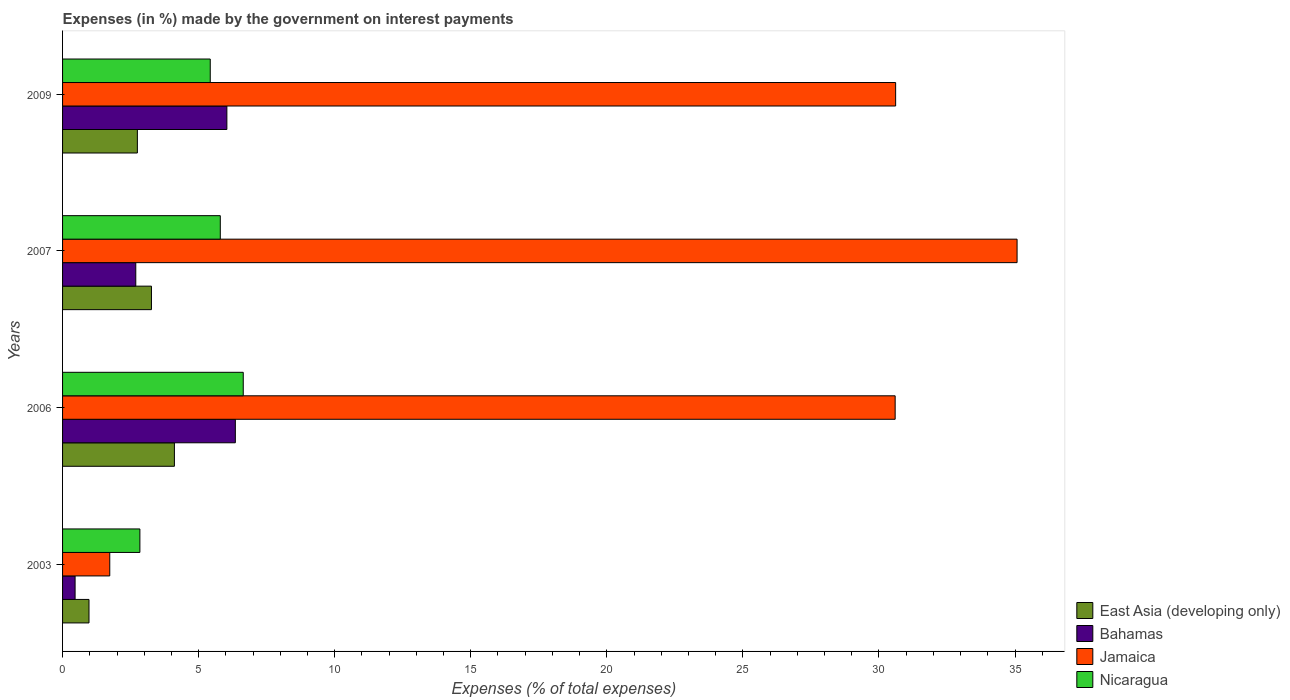How many different coloured bars are there?
Provide a short and direct response. 4. How many groups of bars are there?
Ensure brevity in your answer.  4. Are the number of bars per tick equal to the number of legend labels?
Offer a terse response. Yes. Are the number of bars on each tick of the Y-axis equal?
Give a very brief answer. Yes. What is the label of the 3rd group of bars from the top?
Offer a terse response. 2006. What is the percentage of expenses made by the government on interest payments in Bahamas in 2006?
Provide a succinct answer. 6.35. Across all years, what is the maximum percentage of expenses made by the government on interest payments in Bahamas?
Your answer should be compact. 6.35. Across all years, what is the minimum percentage of expenses made by the government on interest payments in Bahamas?
Provide a succinct answer. 0.46. What is the total percentage of expenses made by the government on interest payments in Bahamas in the graph?
Offer a very short reply. 15.54. What is the difference between the percentage of expenses made by the government on interest payments in Jamaica in 2003 and that in 2006?
Offer a very short reply. -28.86. What is the difference between the percentage of expenses made by the government on interest payments in Nicaragua in 2006 and the percentage of expenses made by the government on interest payments in East Asia (developing only) in 2007?
Your response must be concise. 3.37. What is the average percentage of expenses made by the government on interest payments in Bahamas per year?
Your answer should be very brief. 3.88. In the year 2009, what is the difference between the percentage of expenses made by the government on interest payments in Jamaica and percentage of expenses made by the government on interest payments in Bahamas?
Offer a very short reply. 24.57. In how many years, is the percentage of expenses made by the government on interest payments in Bahamas greater than 20 %?
Offer a very short reply. 0. What is the ratio of the percentage of expenses made by the government on interest payments in Bahamas in 2003 to that in 2009?
Ensure brevity in your answer.  0.08. Is the percentage of expenses made by the government on interest payments in Nicaragua in 2003 less than that in 2009?
Ensure brevity in your answer.  Yes. What is the difference between the highest and the second highest percentage of expenses made by the government on interest payments in Bahamas?
Your answer should be very brief. 0.31. What is the difference between the highest and the lowest percentage of expenses made by the government on interest payments in Nicaragua?
Keep it short and to the point. 3.8. In how many years, is the percentage of expenses made by the government on interest payments in East Asia (developing only) greater than the average percentage of expenses made by the government on interest payments in East Asia (developing only) taken over all years?
Offer a terse response. 2. Is it the case that in every year, the sum of the percentage of expenses made by the government on interest payments in Nicaragua and percentage of expenses made by the government on interest payments in Bahamas is greater than the sum of percentage of expenses made by the government on interest payments in Jamaica and percentage of expenses made by the government on interest payments in East Asia (developing only)?
Ensure brevity in your answer.  No. What does the 2nd bar from the top in 2007 represents?
Your answer should be compact. Jamaica. What does the 4th bar from the bottom in 2003 represents?
Your response must be concise. Nicaragua. Is it the case that in every year, the sum of the percentage of expenses made by the government on interest payments in Nicaragua and percentage of expenses made by the government on interest payments in Bahamas is greater than the percentage of expenses made by the government on interest payments in Jamaica?
Give a very brief answer. No. How many bars are there?
Your answer should be very brief. 16. Are all the bars in the graph horizontal?
Offer a terse response. Yes. What is the difference between two consecutive major ticks on the X-axis?
Offer a very short reply. 5. Are the values on the major ticks of X-axis written in scientific E-notation?
Offer a terse response. No. Does the graph contain any zero values?
Make the answer very short. No. Where does the legend appear in the graph?
Your answer should be very brief. Bottom right. What is the title of the graph?
Make the answer very short. Expenses (in %) made by the government on interest payments. What is the label or title of the X-axis?
Keep it short and to the point. Expenses (% of total expenses). What is the Expenses (% of total expenses) in East Asia (developing only) in 2003?
Give a very brief answer. 0.97. What is the Expenses (% of total expenses) of Bahamas in 2003?
Provide a succinct answer. 0.46. What is the Expenses (% of total expenses) of Jamaica in 2003?
Keep it short and to the point. 1.73. What is the Expenses (% of total expenses) of Nicaragua in 2003?
Your answer should be very brief. 2.84. What is the Expenses (% of total expenses) in East Asia (developing only) in 2006?
Make the answer very short. 4.11. What is the Expenses (% of total expenses) in Bahamas in 2006?
Your response must be concise. 6.35. What is the Expenses (% of total expenses) of Jamaica in 2006?
Provide a succinct answer. 30.6. What is the Expenses (% of total expenses) of Nicaragua in 2006?
Provide a succinct answer. 6.64. What is the Expenses (% of total expenses) in East Asia (developing only) in 2007?
Make the answer very short. 3.27. What is the Expenses (% of total expenses) in Bahamas in 2007?
Give a very brief answer. 2.69. What is the Expenses (% of total expenses) of Jamaica in 2007?
Make the answer very short. 35.08. What is the Expenses (% of total expenses) in Nicaragua in 2007?
Offer a terse response. 5.8. What is the Expenses (% of total expenses) of East Asia (developing only) in 2009?
Keep it short and to the point. 2.75. What is the Expenses (% of total expenses) in Bahamas in 2009?
Make the answer very short. 6.04. What is the Expenses (% of total expenses) in Jamaica in 2009?
Provide a short and direct response. 30.61. What is the Expenses (% of total expenses) of Nicaragua in 2009?
Ensure brevity in your answer.  5.43. Across all years, what is the maximum Expenses (% of total expenses) in East Asia (developing only)?
Provide a succinct answer. 4.11. Across all years, what is the maximum Expenses (% of total expenses) in Bahamas?
Your response must be concise. 6.35. Across all years, what is the maximum Expenses (% of total expenses) of Jamaica?
Your answer should be very brief. 35.08. Across all years, what is the maximum Expenses (% of total expenses) of Nicaragua?
Keep it short and to the point. 6.64. Across all years, what is the minimum Expenses (% of total expenses) of East Asia (developing only)?
Your answer should be compact. 0.97. Across all years, what is the minimum Expenses (% of total expenses) of Bahamas?
Your response must be concise. 0.46. Across all years, what is the minimum Expenses (% of total expenses) of Jamaica?
Offer a terse response. 1.73. Across all years, what is the minimum Expenses (% of total expenses) of Nicaragua?
Provide a short and direct response. 2.84. What is the total Expenses (% of total expenses) of East Asia (developing only) in the graph?
Offer a terse response. 11.1. What is the total Expenses (% of total expenses) in Bahamas in the graph?
Your response must be concise. 15.54. What is the total Expenses (% of total expenses) in Jamaica in the graph?
Give a very brief answer. 98.02. What is the total Expenses (% of total expenses) of Nicaragua in the graph?
Give a very brief answer. 20.7. What is the difference between the Expenses (% of total expenses) in East Asia (developing only) in 2003 and that in 2006?
Your answer should be very brief. -3.14. What is the difference between the Expenses (% of total expenses) in Bahamas in 2003 and that in 2006?
Your response must be concise. -5.89. What is the difference between the Expenses (% of total expenses) of Jamaica in 2003 and that in 2006?
Provide a succinct answer. -28.86. What is the difference between the Expenses (% of total expenses) in Nicaragua in 2003 and that in 2006?
Your answer should be very brief. -3.8. What is the difference between the Expenses (% of total expenses) in East Asia (developing only) in 2003 and that in 2007?
Keep it short and to the point. -2.29. What is the difference between the Expenses (% of total expenses) of Bahamas in 2003 and that in 2007?
Keep it short and to the point. -2.23. What is the difference between the Expenses (% of total expenses) in Jamaica in 2003 and that in 2007?
Your response must be concise. -33.34. What is the difference between the Expenses (% of total expenses) in Nicaragua in 2003 and that in 2007?
Your answer should be compact. -2.95. What is the difference between the Expenses (% of total expenses) in East Asia (developing only) in 2003 and that in 2009?
Ensure brevity in your answer.  -1.78. What is the difference between the Expenses (% of total expenses) in Bahamas in 2003 and that in 2009?
Offer a terse response. -5.58. What is the difference between the Expenses (% of total expenses) of Jamaica in 2003 and that in 2009?
Provide a short and direct response. -28.88. What is the difference between the Expenses (% of total expenses) of Nicaragua in 2003 and that in 2009?
Offer a terse response. -2.59. What is the difference between the Expenses (% of total expenses) in East Asia (developing only) in 2006 and that in 2007?
Your answer should be compact. 0.84. What is the difference between the Expenses (% of total expenses) of Bahamas in 2006 and that in 2007?
Your answer should be compact. 3.66. What is the difference between the Expenses (% of total expenses) of Jamaica in 2006 and that in 2007?
Give a very brief answer. -4.48. What is the difference between the Expenses (% of total expenses) of Nicaragua in 2006 and that in 2007?
Your answer should be very brief. 0.84. What is the difference between the Expenses (% of total expenses) in East Asia (developing only) in 2006 and that in 2009?
Your answer should be compact. 1.36. What is the difference between the Expenses (% of total expenses) of Bahamas in 2006 and that in 2009?
Provide a short and direct response. 0.31. What is the difference between the Expenses (% of total expenses) in Jamaica in 2006 and that in 2009?
Offer a very short reply. -0.02. What is the difference between the Expenses (% of total expenses) in Nicaragua in 2006 and that in 2009?
Offer a very short reply. 1.21. What is the difference between the Expenses (% of total expenses) of East Asia (developing only) in 2007 and that in 2009?
Your answer should be very brief. 0.52. What is the difference between the Expenses (% of total expenses) of Bahamas in 2007 and that in 2009?
Make the answer very short. -3.35. What is the difference between the Expenses (% of total expenses) in Jamaica in 2007 and that in 2009?
Your response must be concise. 4.46. What is the difference between the Expenses (% of total expenses) in Nicaragua in 2007 and that in 2009?
Make the answer very short. 0.37. What is the difference between the Expenses (% of total expenses) of East Asia (developing only) in 2003 and the Expenses (% of total expenses) of Bahamas in 2006?
Provide a succinct answer. -5.38. What is the difference between the Expenses (% of total expenses) of East Asia (developing only) in 2003 and the Expenses (% of total expenses) of Jamaica in 2006?
Provide a succinct answer. -29.62. What is the difference between the Expenses (% of total expenses) of East Asia (developing only) in 2003 and the Expenses (% of total expenses) of Nicaragua in 2006?
Your answer should be very brief. -5.67. What is the difference between the Expenses (% of total expenses) of Bahamas in 2003 and the Expenses (% of total expenses) of Jamaica in 2006?
Keep it short and to the point. -30.13. What is the difference between the Expenses (% of total expenses) in Bahamas in 2003 and the Expenses (% of total expenses) in Nicaragua in 2006?
Ensure brevity in your answer.  -6.18. What is the difference between the Expenses (% of total expenses) of Jamaica in 2003 and the Expenses (% of total expenses) of Nicaragua in 2006?
Keep it short and to the point. -4.91. What is the difference between the Expenses (% of total expenses) in East Asia (developing only) in 2003 and the Expenses (% of total expenses) in Bahamas in 2007?
Make the answer very short. -1.72. What is the difference between the Expenses (% of total expenses) in East Asia (developing only) in 2003 and the Expenses (% of total expenses) in Jamaica in 2007?
Your response must be concise. -34.1. What is the difference between the Expenses (% of total expenses) in East Asia (developing only) in 2003 and the Expenses (% of total expenses) in Nicaragua in 2007?
Your response must be concise. -4.82. What is the difference between the Expenses (% of total expenses) in Bahamas in 2003 and the Expenses (% of total expenses) in Jamaica in 2007?
Ensure brevity in your answer.  -34.61. What is the difference between the Expenses (% of total expenses) in Bahamas in 2003 and the Expenses (% of total expenses) in Nicaragua in 2007?
Make the answer very short. -5.34. What is the difference between the Expenses (% of total expenses) of Jamaica in 2003 and the Expenses (% of total expenses) of Nicaragua in 2007?
Provide a succinct answer. -4.06. What is the difference between the Expenses (% of total expenses) in East Asia (developing only) in 2003 and the Expenses (% of total expenses) in Bahamas in 2009?
Your response must be concise. -5.07. What is the difference between the Expenses (% of total expenses) of East Asia (developing only) in 2003 and the Expenses (% of total expenses) of Jamaica in 2009?
Offer a terse response. -29.64. What is the difference between the Expenses (% of total expenses) in East Asia (developing only) in 2003 and the Expenses (% of total expenses) in Nicaragua in 2009?
Provide a succinct answer. -4.46. What is the difference between the Expenses (% of total expenses) of Bahamas in 2003 and the Expenses (% of total expenses) of Jamaica in 2009?
Give a very brief answer. -30.15. What is the difference between the Expenses (% of total expenses) of Bahamas in 2003 and the Expenses (% of total expenses) of Nicaragua in 2009?
Offer a terse response. -4.97. What is the difference between the Expenses (% of total expenses) in Jamaica in 2003 and the Expenses (% of total expenses) in Nicaragua in 2009?
Your response must be concise. -3.69. What is the difference between the Expenses (% of total expenses) in East Asia (developing only) in 2006 and the Expenses (% of total expenses) in Bahamas in 2007?
Offer a terse response. 1.42. What is the difference between the Expenses (% of total expenses) in East Asia (developing only) in 2006 and the Expenses (% of total expenses) in Jamaica in 2007?
Your answer should be very brief. -30.97. What is the difference between the Expenses (% of total expenses) of East Asia (developing only) in 2006 and the Expenses (% of total expenses) of Nicaragua in 2007?
Offer a very short reply. -1.69. What is the difference between the Expenses (% of total expenses) in Bahamas in 2006 and the Expenses (% of total expenses) in Jamaica in 2007?
Offer a very short reply. -28.73. What is the difference between the Expenses (% of total expenses) of Bahamas in 2006 and the Expenses (% of total expenses) of Nicaragua in 2007?
Provide a short and direct response. 0.55. What is the difference between the Expenses (% of total expenses) in Jamaica in 2006 and the Expenses (% of total expenses) in Nicaragua in 2007?
Keep it short and to the point. 24.8. What is the difference between the Expenses (% of total expenses) of East Asia (developing only) in 2006 and the Expenses (% of total expenses) of Bahamas in 2009?
Your response must be concise. -1.93. What is the difference between the Expenses (% of total expenses) in East Asia (developing only) in 2006 and the Expenses (% of total expenses) in Jamaica in 2009?
Your answer should be compact. -26.5. What is the difference between the Expenses (% of total expenses) of East Asia (developing only) in 2006 and the Expenses (% of total expenses) of Nicaragua in 2009?
Provide a short and direct response. -1.32. What is the difference between the Expenses (% of total expenses) of Bahamas in 2006 and the Expenses (% of total expenses) of Jamaica in 2009?
Give a very brief answer. -24.26. What is the difference between the Expenses (% of total expenses) in Bahamas in 2006 and the Expenses (% of total expenses) in Nicaragua in 2009?
Offer a very short reply. 0.92. What is the difference between the Expenses (% of total expenses) in Jamaica in 2006 and the Expenses (% of total expenses) in Nicaragua in 2009?
Provide a short and direct response. 25.17. What is the difference between the Expenses (% of total expenses) in East Asia (developing only) in 2007 and the Expenses (% of total expenses) in Bahamas in 2009?
Provide a short and direct response. -2.77. What is the difference between the Expenses (% of total expenses) in East Asia (developing only) in 2007 and the Expenses (% of total expenses) in Jamaica in 2009?
Provide a succinct answer. -27.35. What is the difference between the Expenses (% of total expenses) of East Asia (developing only) in 2007 and the Expenses (% of total expenses) of Nicaragua in 2009?
Provide a short and direct response. -2.16. What is the difference between the Expenses (% of total expenses) in Bahamas in 2007 and the Expenses (% of total expenses) in Jamaica in 2009?
Provide a short and direct response. -27.92. What is the difference between the Expenses (% of total expenses) of Bahamas in 2007 and the Expenses (% of total expenses) of Nicaragua in 2009?
Offer a very short reply. -2.74. What is the difference between the Expenses (% of total expenses) of Jamaica in 2007 and the Expenses (% of total expenses) of Nicaragua in 2009?
Provide a succinct answer. 29.65. What is the average Expenses (% of total expenses) in East Asia (developing only) per year?
Your answer should be compact. 2.77. What is the average Expenses (% of total expenses) in Bahamas per year?
Offer a terse response. 3.88. What is the average Expenses (% of total expenses) in Jamaica per year?
Offer a very short reply. 24.5. What is the average Expenses (% of total expenses) in Nicaragua per year?
Keep it short and to the point. 5.18. In the year 2003, what is the difference between the Expenses (% of total expenses) in East Asia (developing only) and Expenses (% of total expenses) in Bahamas?
Make the answer very short. 0.51. In the year 2003, what is the difference between the Expenses (% of total expenses) of East Asia (developing only) and Expenses (% of total expenses) of Jamaica?
Keep it short and to the point. -0.76. In the year 2003, what is the difference between the Expenses (% of total expenses) in East Asia (developing only) and Expenses (% of total expenses) in Nicaragua?
Make the answer very short. -1.87. In the year 2003, what is the difference between the Expenses (% of total expenses) in Bahamas and Expenses (% of total expenses) in Jamaica?
Your response must be concise. -1.27. In the year 2003, what is the difference between the Expenses (% of total expenses) of Bahamas and Expenses (% of total expenses) of Nicaragua?
Provide a succinct answer. -2.38. In the year 2003, what is the difference between the Expenses (% of total expenses) in Jamaica and Expenses (% of total expenses) in Nicaragua?
Offer a terse response. -1.11. In the year 2006, what is the difference between the Expenses (% of total expenses) of East Asia (developing only) and Expenses (% of total expenses) of Bahamas?
Offer a terse response. -2.24. In the year 2006, what is the difference between the Expenses (% of total expenses) in East Asia (developing only) and Expenses (% of total expenses) in Jamaica?
Your response must be concise. -26.49. In the year 2006, what is the difference between the Expenses (% of total expenses) in East Asia (developing only) and Expenses (% of total expenses) in Nicaragua?
Your response must be concise. -2.53. In the year 2006, what is the difference between the Expenses (% of total expenses) of Bahamas and Expenses (% of total expenses) of Jamaica?
Offer a terse response. -24.25. In the year 2006, what is the difference between the Expenses (% of total expenses) of Bahamas and Expenses (% of total expenses) of Nicaragua?
Make the answer very short. -0.29. In the year 2006, what is the difference between the Expenses (% of total expenses) in Jamaica and Expenses (% of total expenses) in Nicaragua?
Keep it short and to the point. 23.96. In the year 2007, what is the difference between the Expenses (% of total expenses) in East Asia (developing only) and Expenses (% of total expenses) in Bahamas?
Provide a succinct answer. 0.58. In the year 2007, what is the difference between the Expenses (% of total expenses) in East Asia (developing only) and Expenses (% of total expenses) in Jamaica?
Give a very brief answer. -31.81. In the year 2007, what is the difference between the Expenses (% of total expenses) in East Asia (developing only) and Expenses (% of total expenses) in Nicaragua?
Offer a very short reply. -2.53. In the year 2007, what is the difference between the Expenses (% of total expenses) in Bahamas and Expenses (% of total expenses) in Jamaica?
Your answer should be very brief. -32.38. In the year 2007, what is the difference between the Expenses (% of total expenses) of Bahamas and Expenses (% of total expenses) of Nicaragua?
Provide a succinct answer. -3.11. In the year 2007, what is the difference between the Expenses (% of total expenses) of Jamaica and Expenses (% of total expenses) of Nicaragua?
Make the answer very short. 29.28. In the year 2009, what is the difference between the Expenses (% of total expenses) of East Asia (developing only) and Expenses (% of total expenses) of Bahamas?
Your answer should be compact. -3.29. In the year 2009, what is the difference between the Expenses (% of total expenses) in East Asia (developing only) and Expenses (% of total expenses) in Jamaica?
Your response must be concise. -27.86. In the year 2009, what is the difference between the Expenses (% of total expenses) in East Asia (developing only) and Expenses (% of total expenses) in Nicaragua?
Offer a very short reply. -2.68. In the year 2009, what is the difference between the Expenses (% of total expenses) in Bahamas and Expenses (% of total expenses) in Jamaica?
Make the answer very short. -24.57. In the year 2009, what is the difference between the Expenses (% of total expenses) in Bahamas and Expenses (% of total expenses) in Nicaragua?
Provide a succinct answer. 0.61. In the year 2009, what is the difference between the Expenses (% of total expenses) in Jamaica and Expenses (% of total expenses) in Nicaragua?
Offer a terse response. 25.19. What is the ratio of the Expenses (% of total expenses) of East Asia (developing only) in 2003 to that in 2006?
Your answer should be very brief. 0.24. What is the ratio of the Expenses (% of total expenses) in Bahamas in 2003 to that in 2006?
Give a very brief answer. 0.07. What is the ratio of the Expenses (% of total expenses) in Jamaica in 2003 to that in 2006?
Ensure brevity in your answer.  0.06. What is the ratio of the Expenses (% of total expenses) in Nicaragua in 2003 to that in 2006?
Make the answer very short. 0.43. What is the ratio of the Expenses (% of total expenses) of East Asia (developing only) in 2003 to that in 2007?
Provide a short and direct response. 0.3. What is the ratio of the Expenses (% of total expenses) in Bahamas in 2003 to that in 2007?
Your answer should be very brief. 0.17. What is the ratio of the Expenses (% of total expenses) in Jamaica in 2003 to that in 2007?
Provide a succinct answer. 0.05. What is the ratio of the Expenses (% of total expenses) of Nicaragua in 2003 to that in 2007?
Your answer should be very brief. 0.49. What is the ratio of the Expenses (% of total expenses) in East Asia (developing only) in 2003 to that in 2009?
Provide a succinct answer. 0.35. What is the ratio of the Expenses (% of total expenses) in Bahamas in 2003 to that in 2009?
Provide a succinct answer. 0.08. What is the ratio of the Expenses (% of total expenses) of Jamaica in 2003 to that in 2009?
Ensure brevity in your answer.  0.06. What is the ratio of the Expenses (% of total expenses) of Nicaragua in 2003 to that in 2009?
Offer a terse response. 0.52. What is the ratio of the Expenses (% of total expenses) in East Asia (developing only) in 2006 to that in 2007?
Provide a short and direct response. 1.26. What is the ratio of the Expenses (% of total expenses) of Bahamas in 2006 to that in 2007?
Your answer should be very brief. 2.36. What is the ratio of the Expenses (% of total expenses) in Jamaica in 2006 to that in 2007?
Provide a short and direct response. 0.87. What is the ratio of the Expenses (% of total expenses) in Nicaragua in 2006 to that in 2007?
Ensure brevity in your answer.  1.15. What is the ratio of the Expenses (% of total expenses) of East Asia (developing only) in 2006 to that in 2009?
Make the answer very short. 1.5. What is the ratio of the Expenses (% of total expenses) in Bahamas in 2006 to that in 2009?
Your answer should be compact. 1.05. What is the ratio of the Expenses (% of total expenses) in Jamaica in 2006 to that in 2009?
Your response must be concise. 1. What is the ratio of the Expenses (% of total expenses) in Nicaragua in 2006 to that in 2009?
Make the answer very short. 1.22. What is the ratio of the Expenses (% of total expenses) of East Asia (developing only) in 2007 to that in 2009?
Keep it short and to the point. 1.19. What is the ratio of the Expenses (% of total expenses) in Bahamas in 2007 to that in 2009?
Give a very brief answer. 0.45. What is the ratio of the Expenses (% of total expenses) in Jamaica in 2007 to that in 2009?
Give a very brief answer. 1.15. What is the ratio of the Expenses (% of total expenses) in Nicaragua in 2007 to that in 2009?
Provide a succinct answer. 1.07. What is the difference between the highest and the second highest Expenses (% of total expenses) of East Asia (developing only)?
Ensure brevity in your answer.  0.84. What is the difference between the highest and the second highest Expenses (% of total expenses) in Bahamas?
Provide a succinct answer. 0.31. What is the difference between the highest and the second highest Expenses (% of total expenses) in Jamaica?
Give a very brief answer. 4.46. What is the difference between the highest and the second highest Expenses (% of total expenses) in Nicaragua?
Your answer should be very brief. 0.84. What is the difference between the highest and the lowest Expenses (% of total expenses) in East Asia (developing only)?
Ensure brevity in your answer.  3.14. What is the difference between the highest and the lowest Expenses (% of total expenses) of Bahamas?
Your answer should be very brief. 5.89. What is the difference between the highest and the lowest Expenses (% of total expenses) of Jamaica?
Make the answer very short. 33.34. What is the difference between the highest and the lowest Expenses (% of total expenses) in Nicaragua?
Provide a succinct answer. 3.8. 